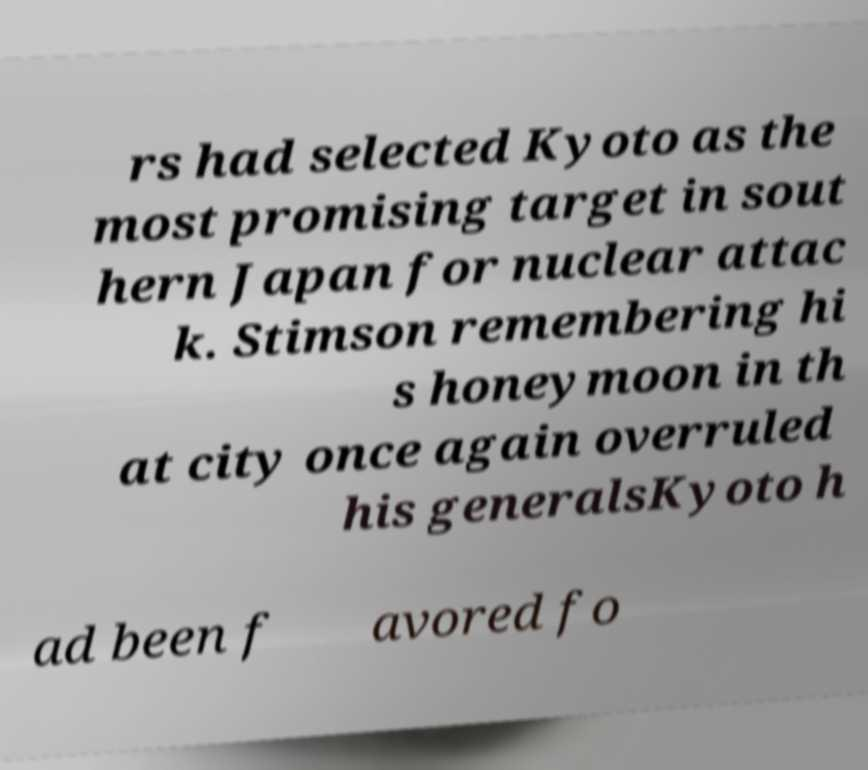There's text embedded in this image that I need extracted. Can you transcribe it verbatim? rs had selected Kyoto as the most promising target in sout hern Japan for nuclear attac k. Stimson remembering hi s honeymoon in th at city once again overruled his generalsKyoto h ad been f avored fo 